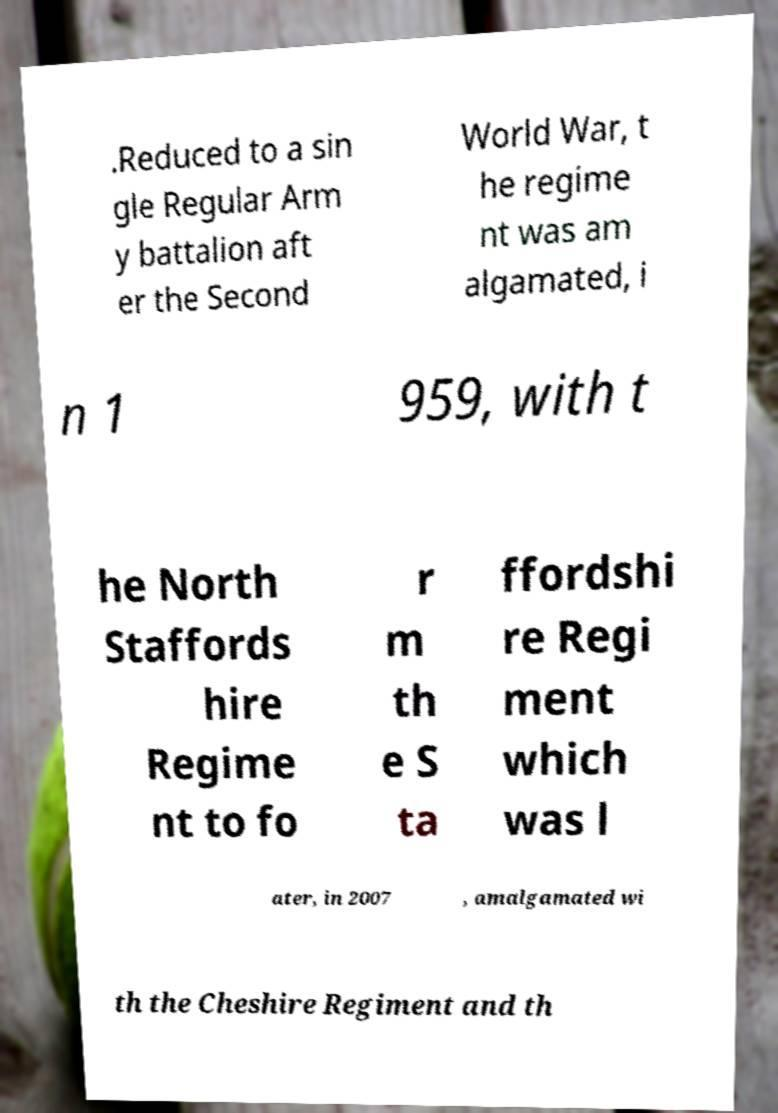Can you read and provide the text displayed in the image?This photo seems to have some interesting text. Can you extract and type it out for me? .Reduced to a sin gle Regular Arm y battalion aft er the Second World War, t he regime nt was am algamated, i n 1 959, with t he North Staffords hire Regime nt to fo r m th e S ta ffordshi re Regi ment which was l ater, in 2007 , amalgamated wi th the Cheshire Regiment and th 